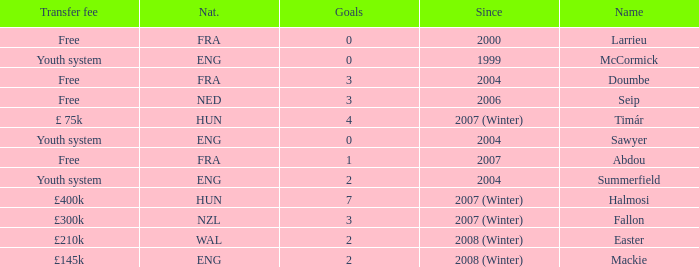What is the since year for the player with more than 3 goals and a transfer fee of £400k? 2007 (Winter). 